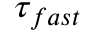<formula> <loc_0><loc_0><loc_500><loc_500>\tau _ { f a s t }</formula> 